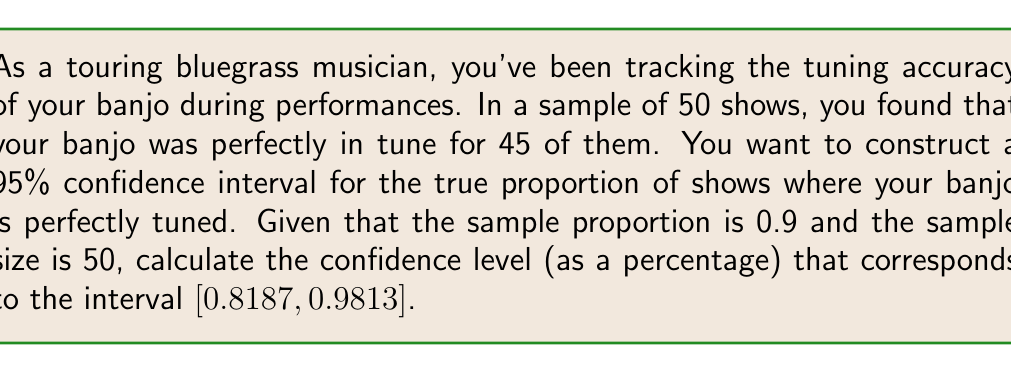Could you help me with this problem? Let's approach this step-by-step:

1) The general formula for a confidence interval for a proportion is:

   $$\hat{p} \pm z_{\alpha/2} \sqrt{\frac{\hat{p}(1-\hat{p})}{n}}$$

   where $\hat{p}$ is the sample proportion, $n$ is the sample size, and $z_{\alpha/2}$ is the critical value.

2) We're given that $\hat{p} = 0.9$ and $n = 50$.

3) The margin of error is the difference between the point estimate and the confidence limit:

   $0.9813 - 0.9 = 0.0813$

4) Using the margin of error formula:

   $$0.0813 = z_{\alpha/2} \sqrt{\frac{0.9(1-0.9)}{50}}$$

5) Solve for $z_{\alpha/2}$:

   $$z_{\alpha/2} = \frac{0.0813}{\sqrt{\frac{0.9(0.1)}{50}}} = 2.5758$$

6) This $z_{\alpha/2}$ value corresponds to a two-tailed probability. To find the confidence level, we need to find the area between $-z_{\alpha/2}$ and $z_{\alpha/2}$ in the standard normal distribution.

7) Using a standard normal table or calculator, we find:
   
   $P(-2.5758 < Z < 2.5758) = 0.99$$

8) Convert to a percentage:

   $0.99 * 100\% = 99\%$

Therefore, the confidence level is 99%.
Answer: 99% 